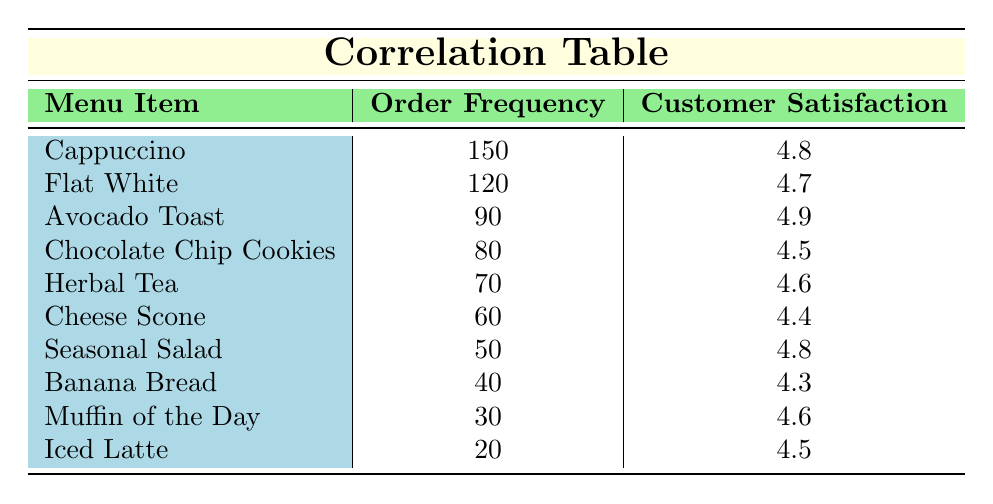What is the customer satisfaction rating for Cappuccino? The table shows a specific row for "Cappuccino," and under the "Customer Satisfaction" column, the value is 4.8.
Answer: 4.8 How many orders were placed for Flat White? The "Order Frequency" column for "Flat White" in the table lists 120, indicating that 120 orders were placed for this item.
Answer: 120 Which menu item has the highest customer satisfaction rating? By scanning the "Customer Satisfaction" column, "Avocado Toast" has the highest rating of 4.9 when compared to others.
Answer: Avocado Toast What is the average order frequency for all the menu items? To find the average, first sum all the order frequencies: 150 + 120 + 90 + 80 + 70 + 60 + 50 + 40 + 30 + 20 = 750. Then divide by the total number of items (10): 750/10 = 75.
Answer: 75 Is it true that Seasonal Salad has a higher customer satisfaction rating than Cheese Scone? Looking at the "Customer Satisfaction" ratings, Seasonal Salad has 4.8 while Cheese Scone has 4.4. Since 4.8 is greater than 4.4, the statement is true.
Answer: Yes Which menu item has a lower order frequency: Muffin of the Day or Iced Latte? The order frequencies are 30 for "Muffin of the Day" and 20 for "Iced Latte." Since 20 is less than 30, Iced Latte has a lower order frequency.
Answer: Iced Latte If we consider the ratings above 4.5, how many menu items meet this criterion? The items meeting this criterion are Cappuccino (4.8), Flat White (4.7), Avocado Toast (4.9), Herbal Tea (4.6), Seasonal Salad (4.8), Muffin of the Day (4.6), and Iced Latte (4.5). Counting these yields 7 items.
Answer: 7 What is the difference in customer satisfaction rating between the highest and lowest rated menu items? The highest rating is 4.9 for Avocado Toast, and the lowest is 4.3 for Banana Bread. The difference is 4.9 - 4.3 = 0.6.
Answer: 0.6 Is Chocolate Chip Cookies the most frequently ordered item? Checking the "Order Frequency" column, "Cappuccino" has the highest frequency at 150, and Chocolate Chip Cookies has a frequency of 80, so the statement is false.
Answer: No What is the total customer satisfaction rating if all the items are considered? Summing the ratings: 4.8 + 4.7 + 4.9 + 4.5 + 4.6 + 4.4 + 4.8 + 4.3 + 4.6 + 4.5 = 46.6.
Answer: 46.6 